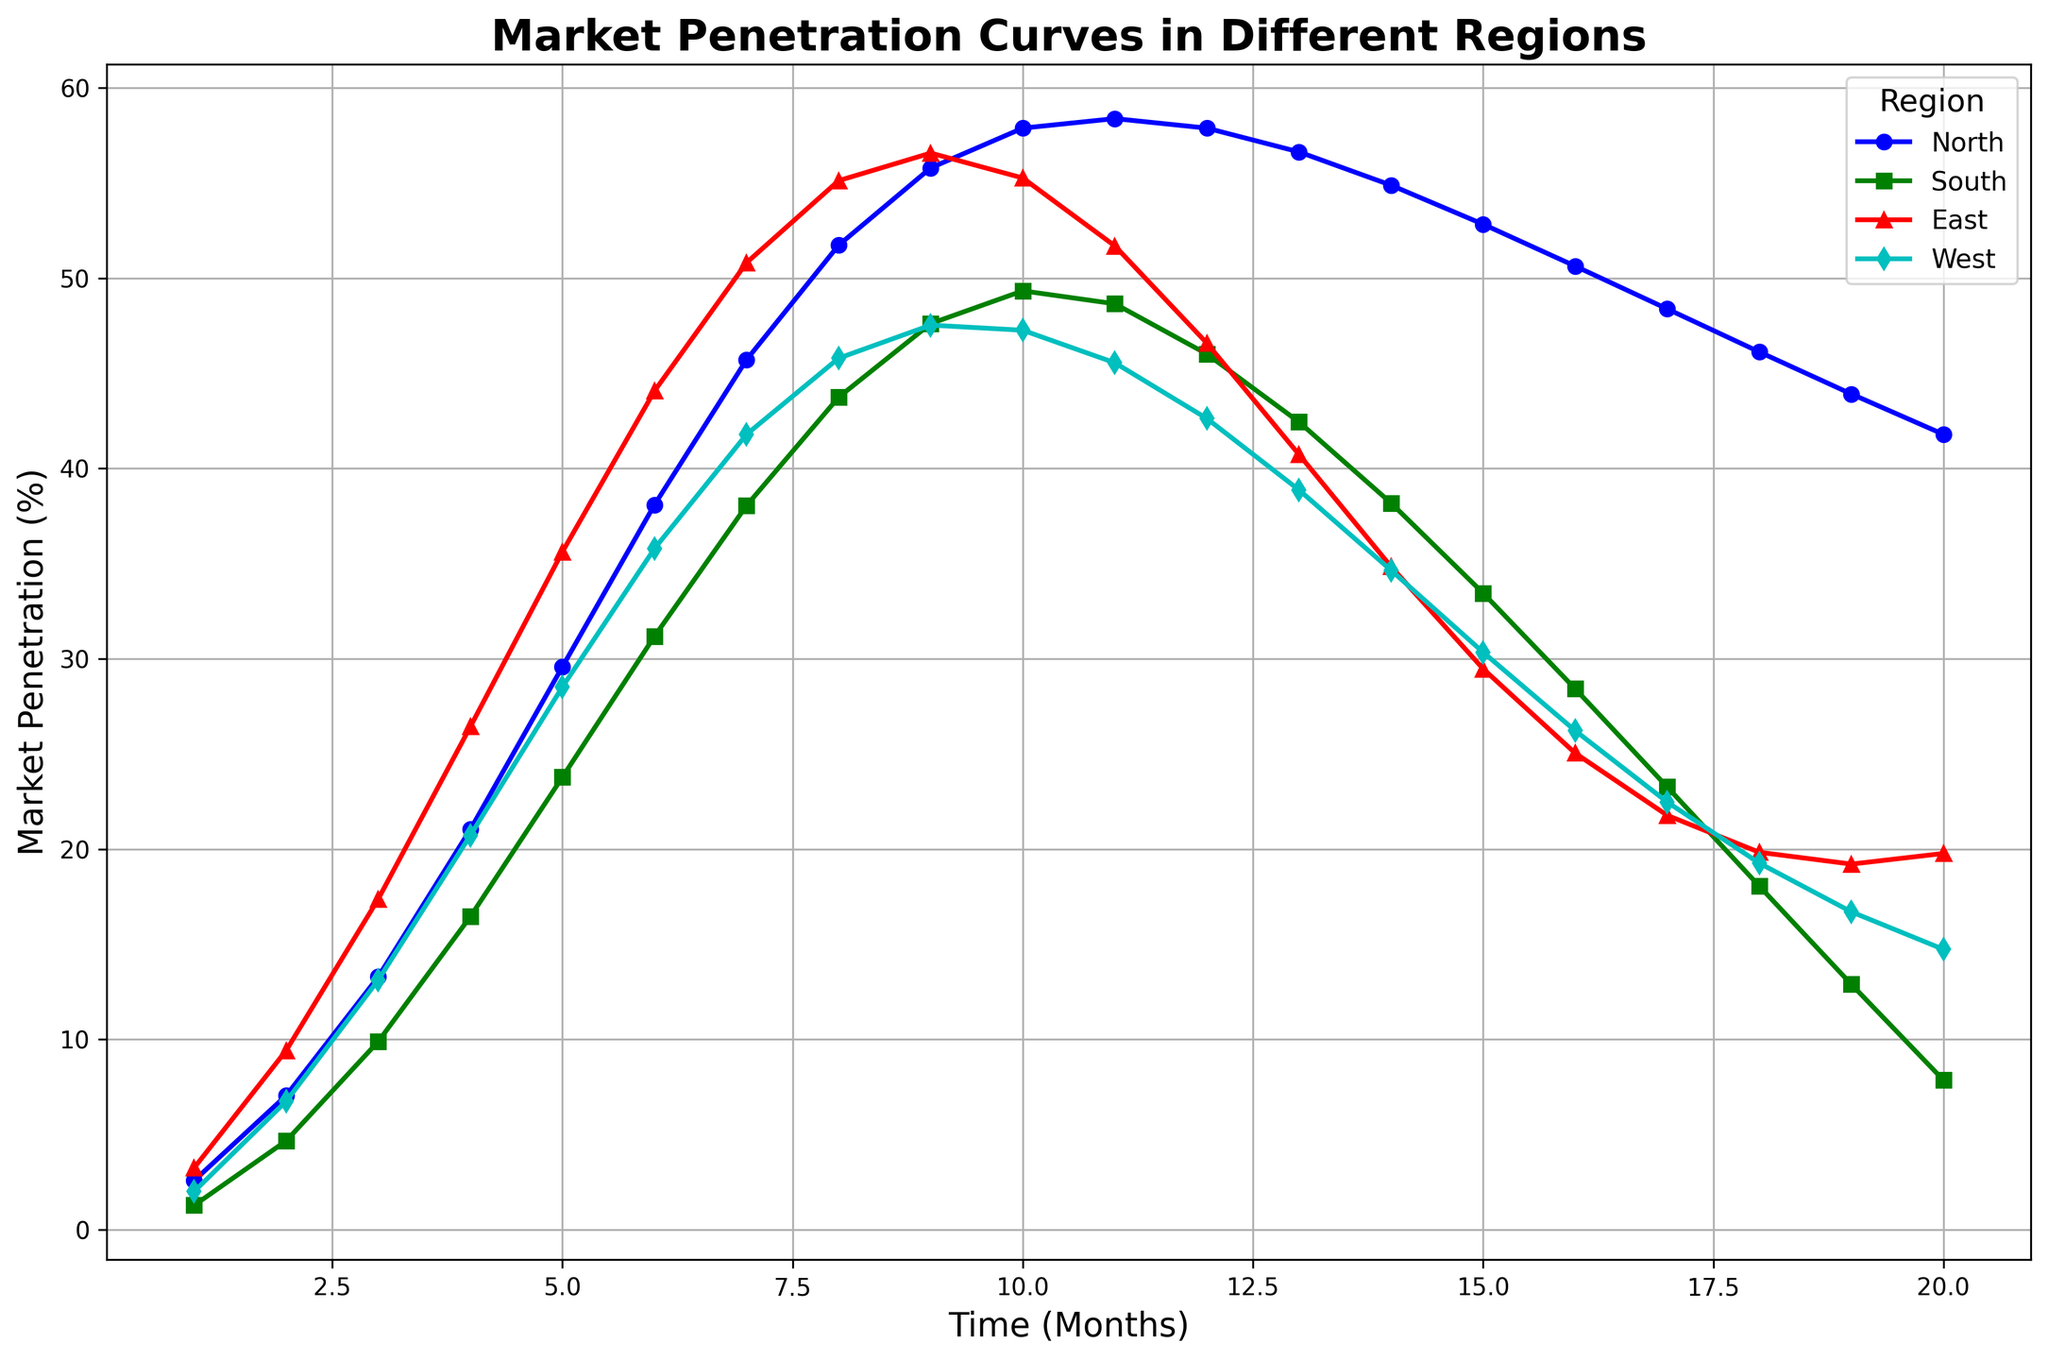What is the highest market penetration percentage in the North region? Identify the peak point in the North region curve. The peak market penetration is around the 11th month.
Answer: 58.38 Which region starts with the highest market penetration percentage and what is that value? Look at the starting values (Time = 1) for all regions. The East region starts with the highest at approximately 3.25%.
Answer: East, 3.25 Between months 10 and 20, which region shows a notable decline in market penetration? Observe the slope of the curves between months 10 and 20 for all regions. The South region shows the most significant decline.
Answer: South In which month does the East region reach its maximum market penetration percentage? Identify the highest point on the East region curve. This peak is observed around the 9th month.
Answer: Month 9 Which region has the lowest market penetration at the end of the observation period? Check the market penetration values at Time = 20 for all regions. The South region has the lowest value.
Answer: South How much does the market penetration increase in the West region from month 3 to month 6? Calculate the difference in market penetration from month 3 to month 6 for the West region (35.79 - 13.12).
Answer: 22.67 Which region's market penetration growth stabilizes the earliest, and in which month? Identify where each region's curve starts to flatten. The North region stabilizes first at around month 10.
Answer: North, Month 10 In which month do the West and South regions have approximately equal market penetration percentages, and what is that value? Find the intersection point of the West and South curves. They intersect around the 8th month at approximately 45%.
Answer: Month 8, 45 What is the total market penetration change in the East region from month 1 to month 20? Calculate the difference in market penetration from month 1 to month 20 for the East region (19.77 - 3.25).
Answer: 16.52 Which region shows a continuous increase in market penetration until month 10 without any decline? Check each region's curve up to month 10 for continuous growth. The South region shows continuous growth until month 10.
Answer: South 